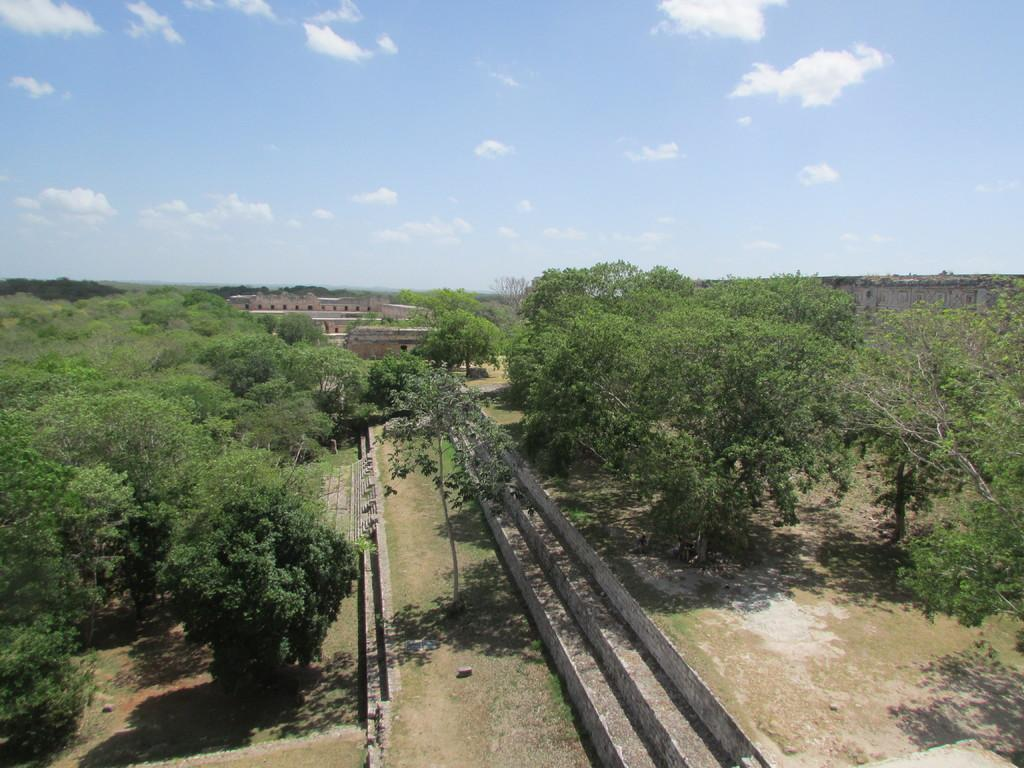What type of structure is visible in the image? There is a building in the image. What feature is present in front of the building? The building has long steps in front of it. What can be seen on either side of the building? There are trees on either side of the building. What is visible in the background of the image? The sky is visible in the image, and clouds are present in the sky. Can you tell me how the boy is pulling the health out of the trees in the image? There is no boy or health present in the image; it features a building with trees on either side and a sky with clouds. 